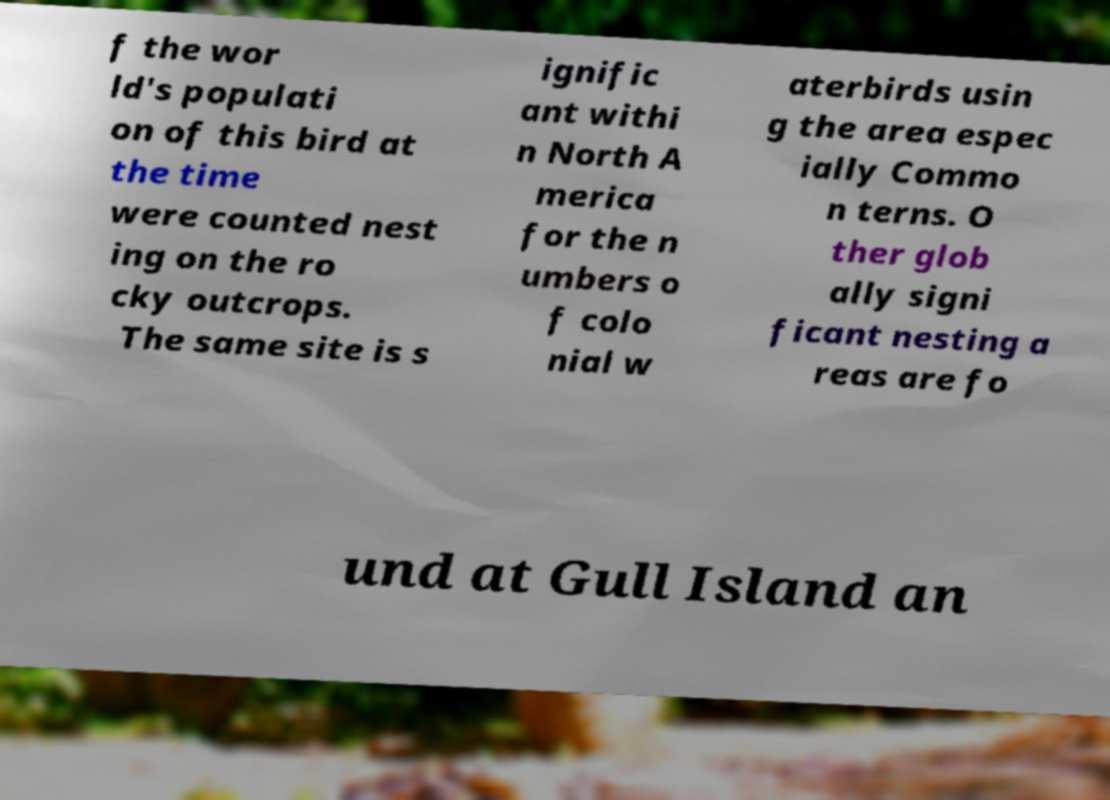Please read and relay the text visible in this image. What does it say? f the wor ld's populati on of this bird at the time were counted nest ing on the ro cky outcrops. The same site is s ignific ant withi n North A merica for the n umbers o f colo nial w aterbirds usin g the area espec ially Commo n terns. O ther glob ally signi ficant nesting a reas are fo und at Gull Island an 